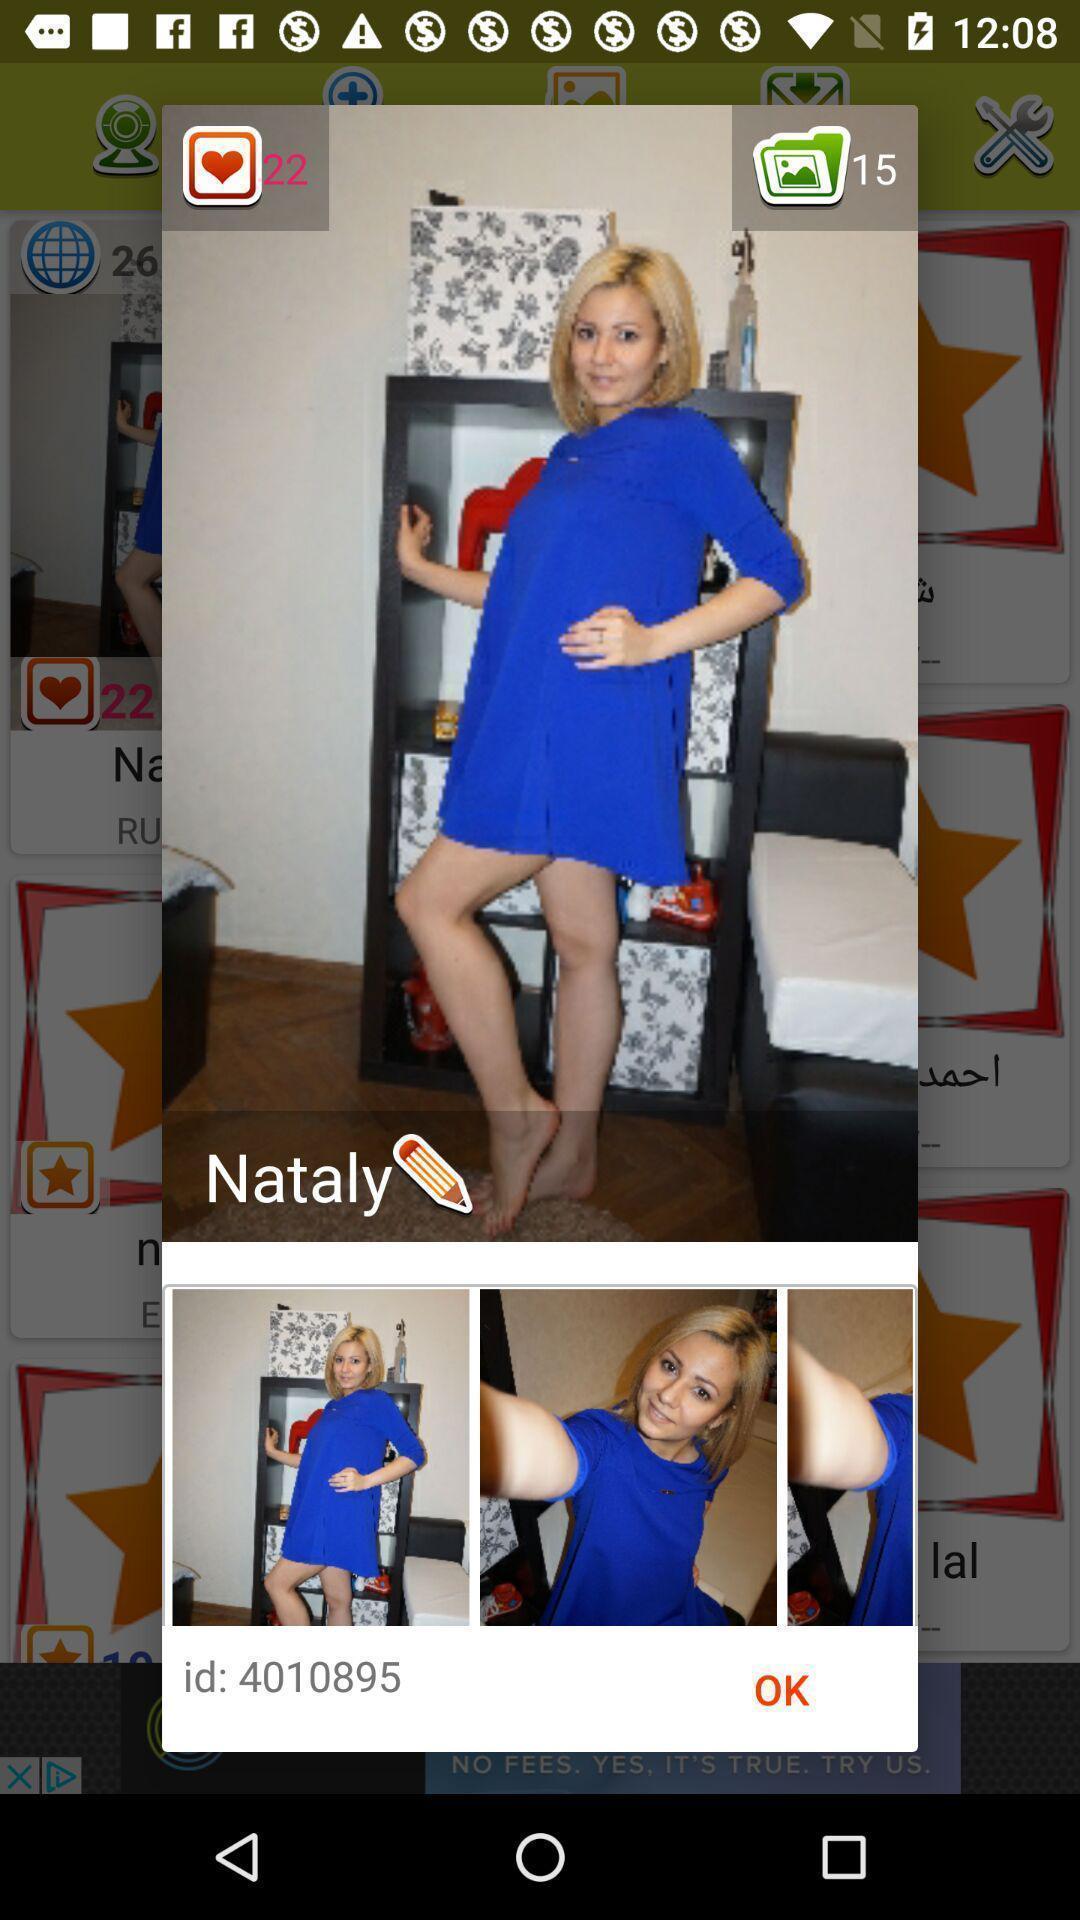Provide a description of this screenshot. Pop-up showing the images of a girl. 